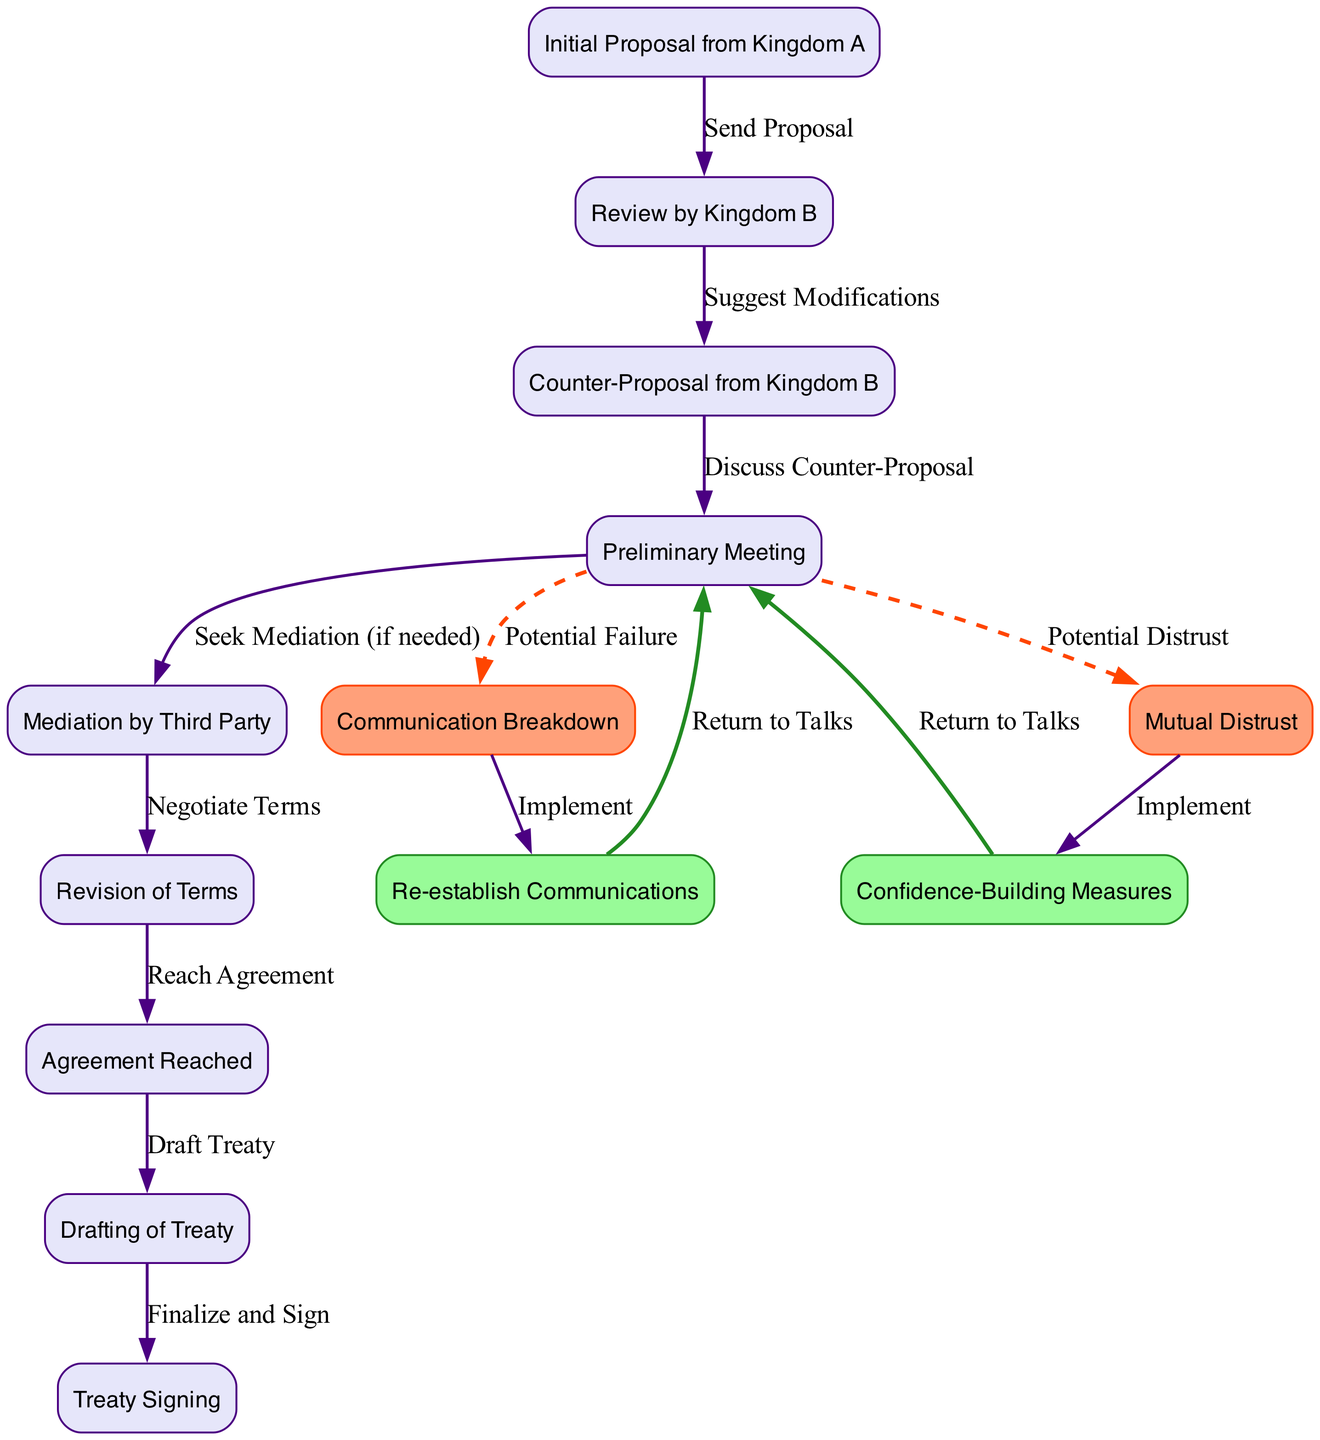What is the first step in the negotiation process? The diagram shows "Initial Proposal from Kingdom A" as the first node, indicating that this is the starting point of the negotiation process.
Answer: Initial Proposal from Kingdom A How many obstacles are represented in the diagram? The diagram includes two nodes labeled "Communication Breakdown" and "Mutual Distrust", which represent the obstacles in the negotiation process, hence there are two obstacles.
Answer: 2 What does the edge from "preliminary_meeting" to "mediation" indicate? The edge from "preliminary_meeting" to "mediation" labeled "Seek Mediation (if needed)" indicates that if the preliminary meeting does not lead to agreement, mediation may be sought as a solution.
Answer: Seek Mediation (if needed) What is the relationship between "mediation" and "revision"? The edge from "mediation" to "revision" labeled "Negotiate Terms" shows that mediation leads into a phase where the involved parties negotiate the terms of the agreement, thus establishing a direct connection between them.
Answer: Negotiate Terms What can be implemented to resolve "Communication Breakdown"? The "resolution1" node labeled "Re-establish Communications" provides the solution for the obstacle "Communication Breakdown", indicating that the way to overcome this issue is by restoring communication.
Answer: Re-establish Communications How does one return to talks after resolving "Mutual Distrust"? The edge connecting "resolution2" to "preliminary_meeting" labeled "Return to Talks" indicates that after implementing confidence-building measures, the negotiating parties can return to the preliminary meeting to continue discussions.
Answer: Return to Talks What is the last step in the negotiation process? The final node in the diagram is "Treaty Signing", which indicates that signing the treaty is the last step in the process after all negotiations and agreements have been reached.
Answer: Treaty Signing What follows an "Agreement Reached"? After the node labeled "Agreement Reached", the next step indicated in the diagram is "Drafting of Treaty", showing that drafting occurs right after an agreement is made.
Answer: Drafting of Treaty What type of negotiation is indicated when facing an obstacle? The edge leading from "preliminary meeting" to "mediation" indicates that mediation can be employed when an obstacle occurs in the negotiation process, allowing for external assistance.
Answer: Mediation 